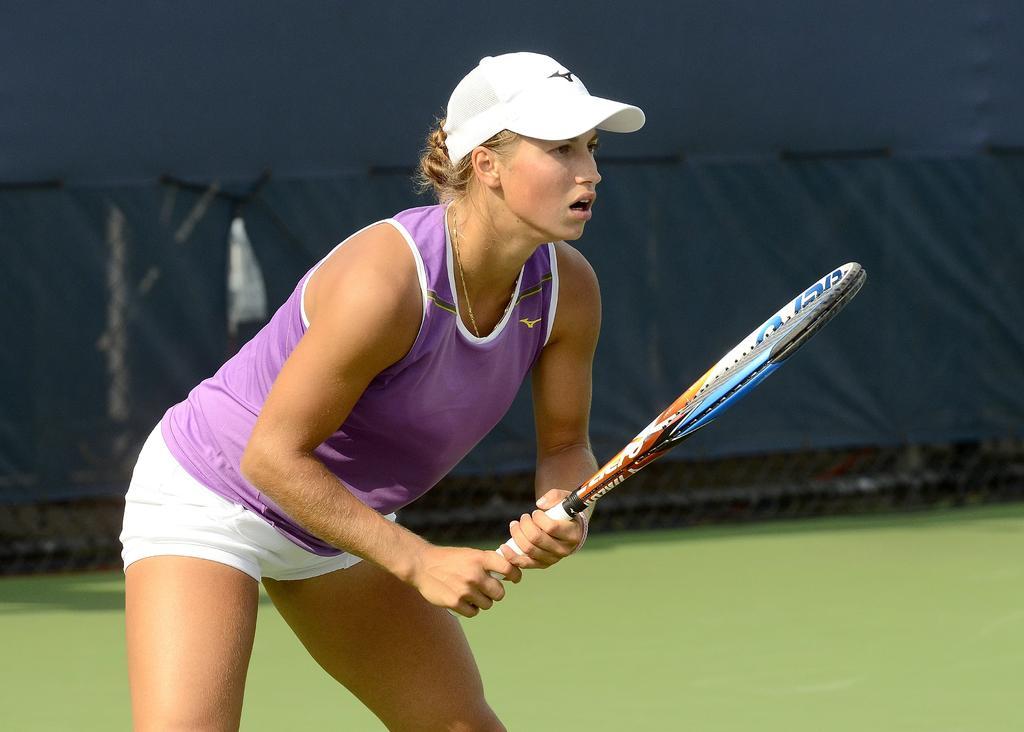Could you give a brief overview of what you see in this image? In this image there is a person wearing sports dress playing tennis. 